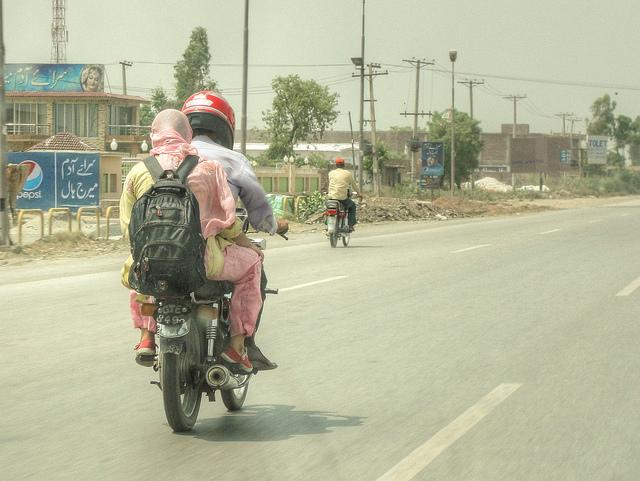Why is the air so hazy? Please explain your reasoning. smog. This city has extremely polluted air. 